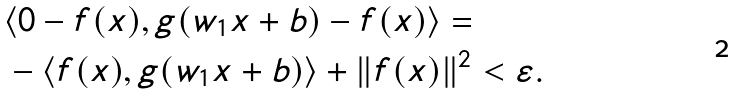<formula> <loc_0><loc_0><loc_500><loc_500>& \langle 0 - f ( x ) , g ( w _ { 1 } x + b ) - f ( x ) \rangle = \\ & - \langle f ( x ) , g ( w _ { 1 } x + b ) \rangle + \| f ( x ) \| ^ { 2 } < \varepsilon .</formula> 